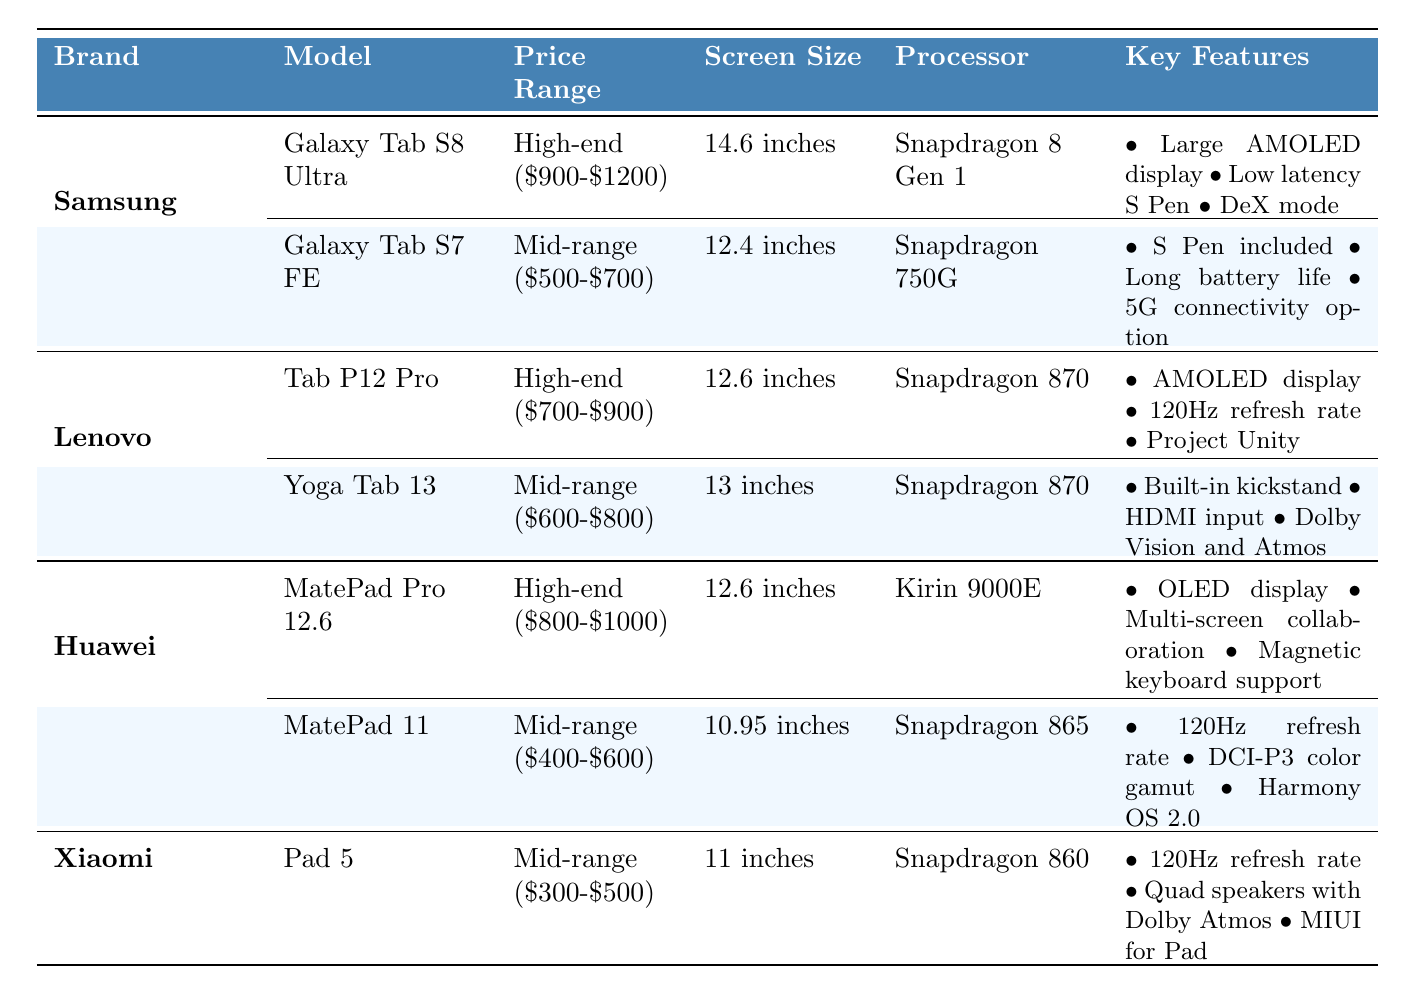What is the price range of the Galaxy Tab S8 Ultra? The table lists the Galaxy Tab S8 Ultra under the brand Samsung. The associated price range provided is "High-end ($900-$1200)."
Answer: High-end ($900-$1200) Which tablet has the largest screen size? By comparing the screen sizes in the table, the Galaxy Tab S8 Ultra has the largest screen size at 14.6 inches.
Answer: Galaxy Tab S8 Ultra Does the Yoga Tab 13 have stylus support? Checking the table, the Yoga Tab 13 is listed as having "Stylus Support: Yes (sold separately)," indicating it does support a stylus.
Answer: Yes Which model has the highest resolution among the listed tablets? The resolution of each model is considered: Galaxy Tab S8 Ultra (2960 x 1848), Galaxy Tab S7 FE (2560 x 1600), and others. Galaxy Tab S8 Ultra has the highest resolution.
Answer: Galaxy Tab S8 Ultra Is the Lenovo Tab P12 Pro more expensive than the Huawei MatePad 11? The price range of the Lenovo Tab P12 Pro is High-end ($700-$900), while the Huawei MatePad 11 is Mid-range ($400-$600). Therefore, the Lenovo Tab P12 Pro is more expensive.
Answer: Yes Which tablet has a lower RAM option: Galaxy Tab S7 FE or MatePad 11? Reviewing the RAM specifications: Galaxy Tab S7 FE has options of 4GB-6GB and MatePad 11 has 6GB. The Galaxy Tab S7 FE has the lower RAM option.
Answer: Galaxy Tab S7 FE What are the two main advantages of the MatePad Pro 12.6 according to the table? In the key features for the MatePad Pro 12.6, "OLED display" and "Multi-screen collaboration" are listed as key advantages.
Answer: OLED display and Multi-screen collaboration If you only consider Mid-range tablets, which one has the largest storage capacity? Among Mid-range tablets, the Galaxy Tab S7 FE and MatePad 11 both have storage options, but the Galaxy Tab S7 FE offers up to 128GB and MatePad 11 offers 128GB as well. The Xiaomi Pad 5 has an upper limit of 256GB. Therefore, the Xiaomi Pad 5 has the largest storage capacity among the Mid-range tablets listed.
Answer: Xiaomi Pad 5 Which brand has the tablet with the highest refresh rate mentioned? The highest refresh rate among the tablets is 120Hz, available on the Lenovo Tab P12 Pro, Huawei MatePad 11, and Xiaomi Pad 5. However, since the question asks for the brand, it can be confirmed as Lenovo, Huawei, and Xiaomi all have this refresh rate associated with different models.
Answer: Lenovo, Huawei, Xiaomi How many brands have high-end tablets listed? By looking at the brands in the table, Samsung, Lenovo, and Huawei all have high-end tablets in the list. That makes a total of three brands with high-end tablets listed.
Answer: 3 What is the RAM range of the Galaxy Tab S8 Ultra? The RAM specification for the Galaxy Tab S8 Ultra is listed as 8GB-16GB.
Answer: 8GB-16GB 